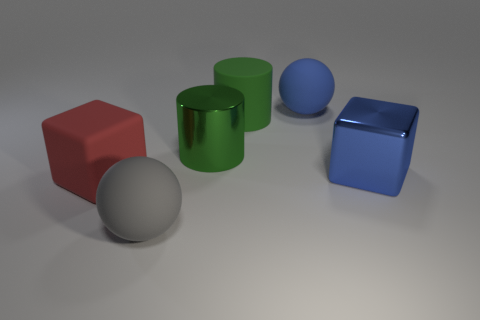What is the color of the ball that is behind the large ball that is in front of the blue matte ball?
Your response must be concise. Blue. The rubber cube that is the same size as the blue metal thing is what color?
Your response must be concise. Red. Is there a gray object that has the same shape as the green metal thing?
Your answer should be very brief. No. What is the shape of the big blue metal object?
Ensure brevity in your answer.  Cube. Is the number of large green rubber objects that are behind the blue rubber object greater than the number of green metal cylinders that are right of the big blue shiny thing?
Your answer should be compact. No. How many other things are there of the same size as the red thing?
Make the answer very short. 5. There is a thing that is both in front of the big green metal cylinder and to the right of the green rubber cylinder; what is its material?
Your answer should be compact. Metal. There is another green object that is the same shape as the large green rubber object; what is it made of?
Your answer should be very brief. Metal. How many big things are on the left side of the large sphere in front of the large cube that is behind the large red cube?
Your answer should be compact. 1. Is there any other thing that has the same color as the shiny cube?
Provide a succinct answer. Yes. 